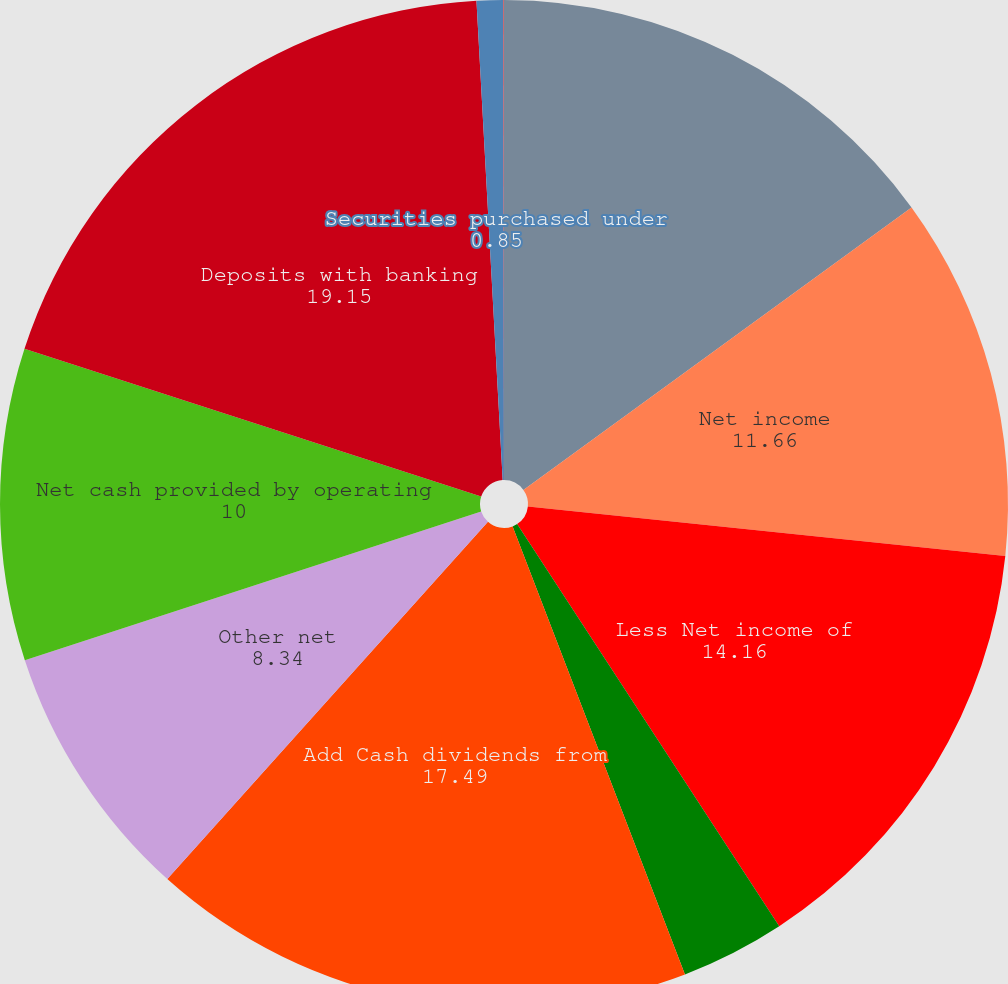<chart> <loc_0><loc_0><loc_500><loc_500><pie_chart><fcel>Year ended December 31 (in<fcel>Net income<fcel>Less Net income of<fcel>Parent company net loss<fcel>Add Cash dividends from<fcel>Other net<fcel>Net cash provided by operating<fcel>Deposits with banking<fcel>Securities purchased under<fcel>Loans<nl><fcel>14.99%<fcel>11.66%<fcel>14.16%<fcel>3.35%<fcel>17.49%<fcel>8.34%<fcel>10.0%<fcel>19.15%<fcel>0.85%<fcel>0.02%<nl></chart> 